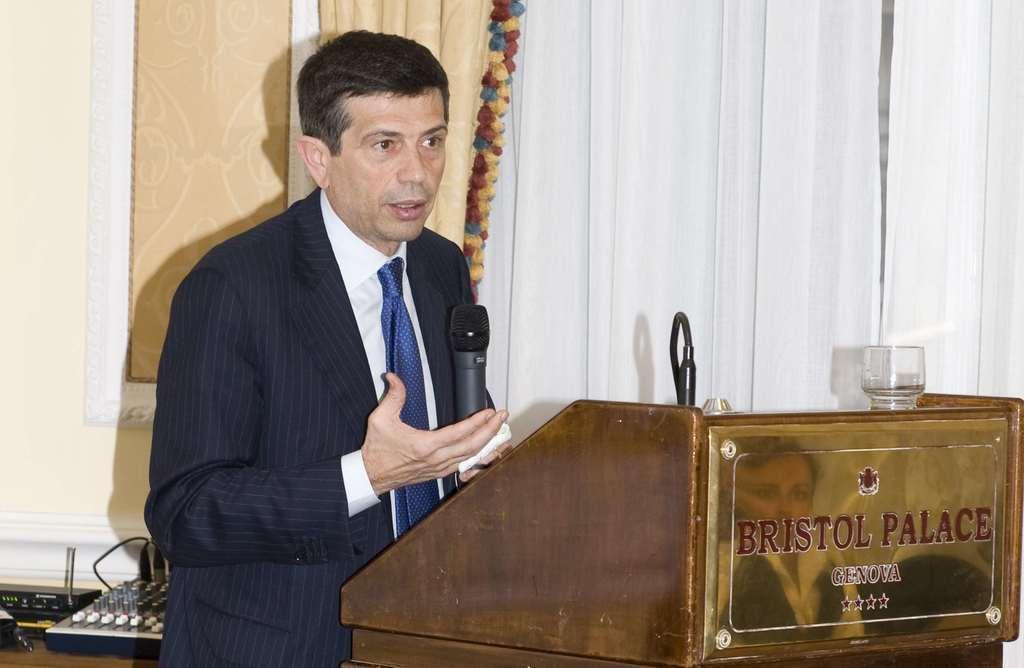Can you describe this image briefly? Here in this picture we can see a person wearing a suit and standing over a place and speaking something in the microphone present in his hand and in front of him we can see a speech desk present and on that we can see a glass and behind him we can see some electronic equipments present on a table and beside him we can see curtains present. 